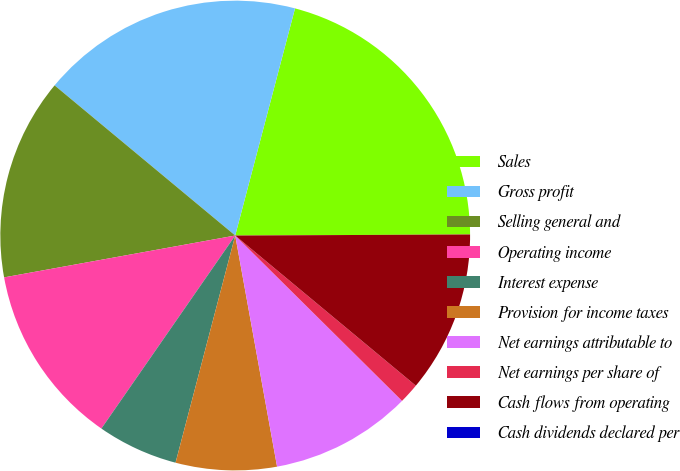<chart> <loc_0><loc_0><loc_500><loc_500><pie_chart><fcel>Sales<fcel>Gross profit<fcel>Selling general and<fcel>Operating income<fcel>Interest expense<fcel>Provision for income taxes<fcel>Net earnings attributable to<fcel>Net earnings per share of<fcel>Cash flows from operating<fcel>Cash dividends declared per<nl><fcel>20.83%<fcel>18.06%<fcel>13.89%<fcel>12.5%<fcel>5.56%<fcel>6.94%<fcel>9.72%<fcel>1.39%<fcel>11.11%<fcel>0.0%<nl></chart> 